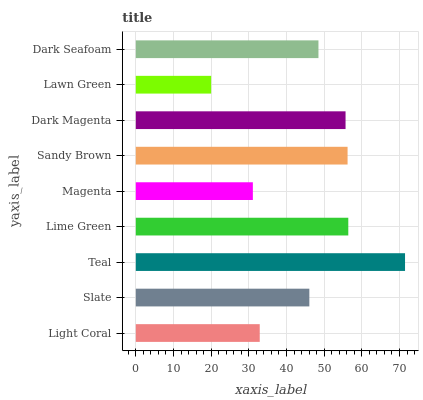Is Lawn Green the minimum?
Answer yes or no. Yes. Is Teal the maximum?
Answer yes or no. Yes. Is Slate the minimum?
Answer yes or no. No. Is Slate the maximum?
Answer yes or no. No. Is Slate greater than Light Coral?
Answer yes or no. Yes. Is Light Coral less than Slate?
Answer yes or no. Yes. Is Light Coral greater than Slate?
Answer yes or no. No. Is Slate less than Light Coral?
Answer yes or no. No. Is Dark Seafoam the high median?
Answer yes or no. Yes. Is Dark Seafoam the low median?
Answer yes or no. Yes. Is Dark Magenta the high median?
Answer yes or no. No. Is Magenta the low median?
Answer yes or no. No. 